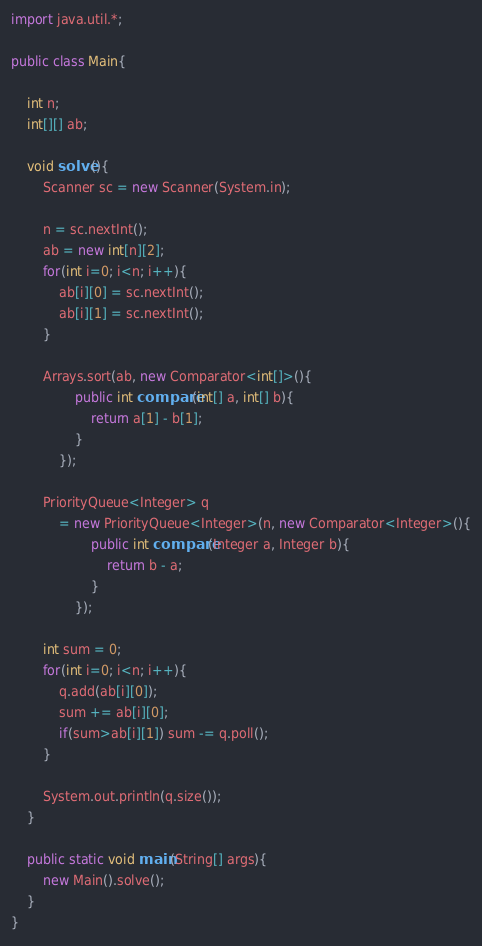Convert code to text. <code><loc_0><loc_0><loc_500><loc_500><_Java_>import java.util.*;

public class Main{

    int n;
    int[][] ab;

    void solve(){
        Scanner sc = new Scanner(System.in);

        n = sc.nextInt();
        ab = new int[n][2];
        for(int i=0; i<n; i++){
            ab[i][0] = sc.nextInt();
            ab[i][1] = sc.nextInt();
        }

        Arrays.sort(ab, new Comparator<int[]>(){
                public int compare(int[] a, int[] b){
                    return a[1] - b[1];
                }
            });

        PriorityQueue<Integer> q 
            = new PriorityQueue<Integer>(n, new Comparator<Integer>(){
                    public int compare(Integer a, Integer b){
                        return b - a;
                    }
                });

        int sum = 0;
        for(int i=0; i<n; i++){
            q.add(ab[i][0]);
            sum += ab[i][0];
            if(sum>ab[i][1]) sum -= q.poll();
        }

        System.out.println(q.size());
    }

    public static void main(String[] args){
        new Main().solve();
    }
}</code> 